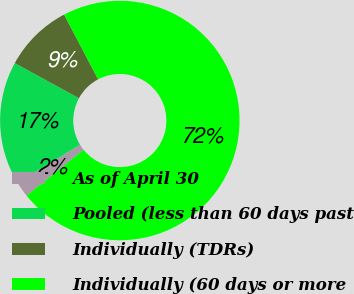Convert chart to OTSL. <chart><loc_0><loc_0><loc_500><loc_500><pie_chart><fcel>As of April 30<fcel>Pooled (less than 60 days past<fcel>Individually (TDRs)<fcel>Individually (60 days or more<nl><fcel>2.1%<fcel>16.67%<fcel>9.33%<fcel>71.9%<nl></chart> 